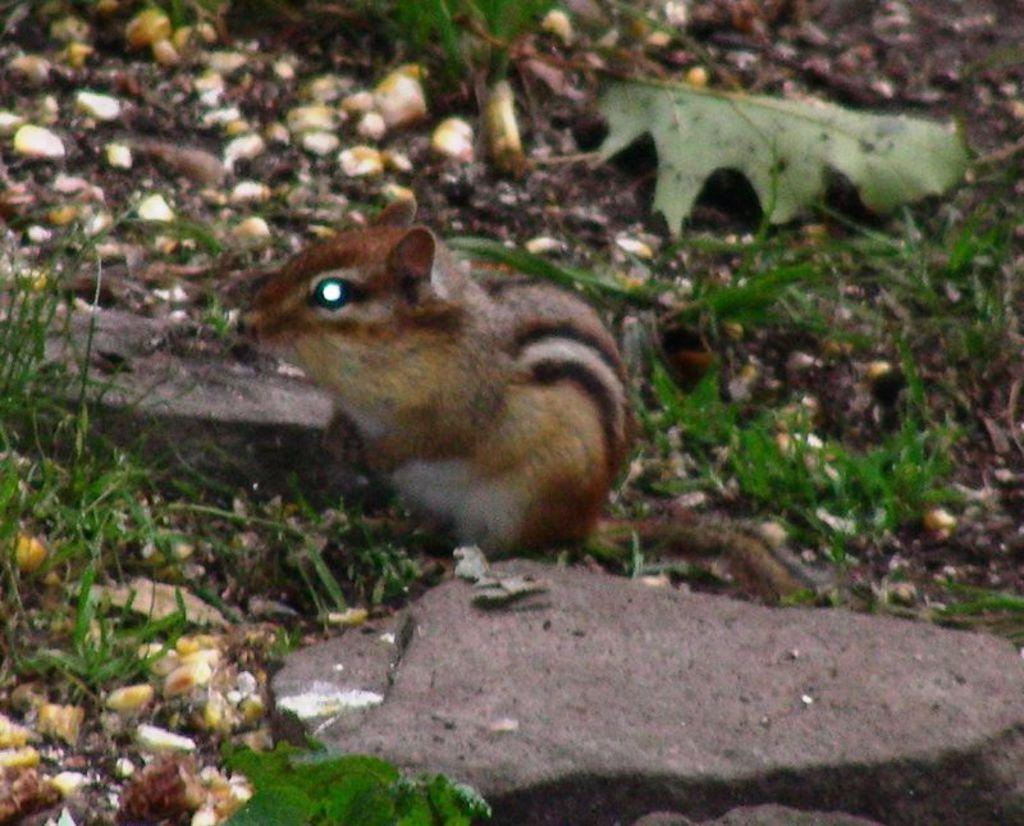What type of animal is in the image? There is a brown squirrel in the image. Where is the squirrel located in the image? The squirrel is sitting on the ground. What can be seen on the ground in the image? There are stones on the ground in the image. What type of vegetation is visible in the image? There are green leaves and grass visible in the image. What type of wine is the squirrel holding in the image? There is no wine present in the image; it features a brown squirrel sitting on the ground. 